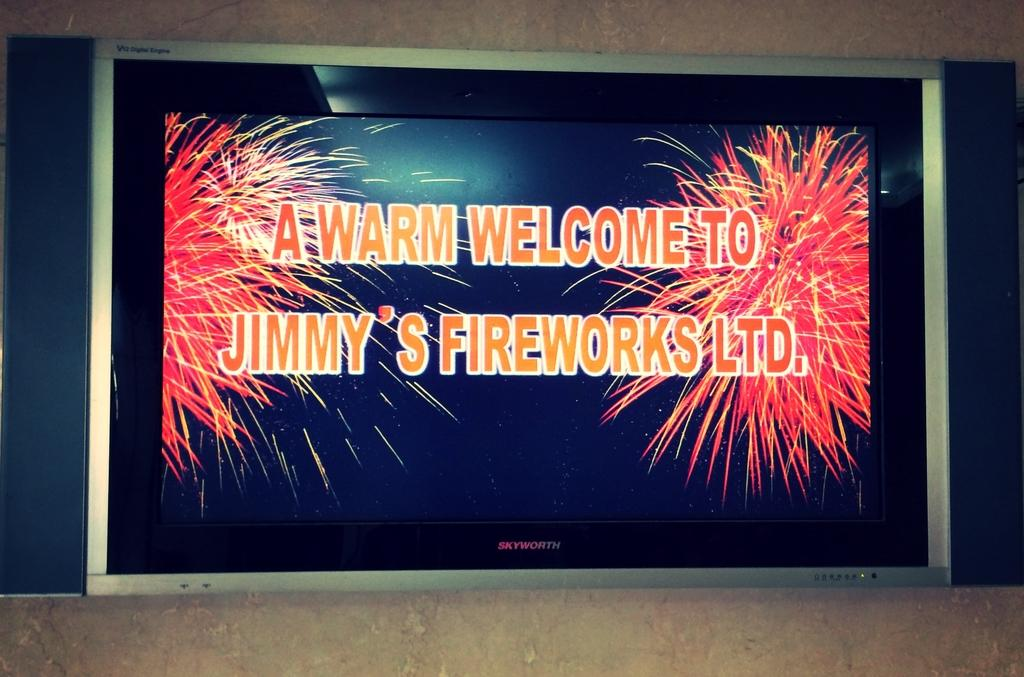Provide a one-sentence caption for the provided image. A screen displays a picture that states "A Warm Welcome to Jimmy's Fireworks Ltd.". 